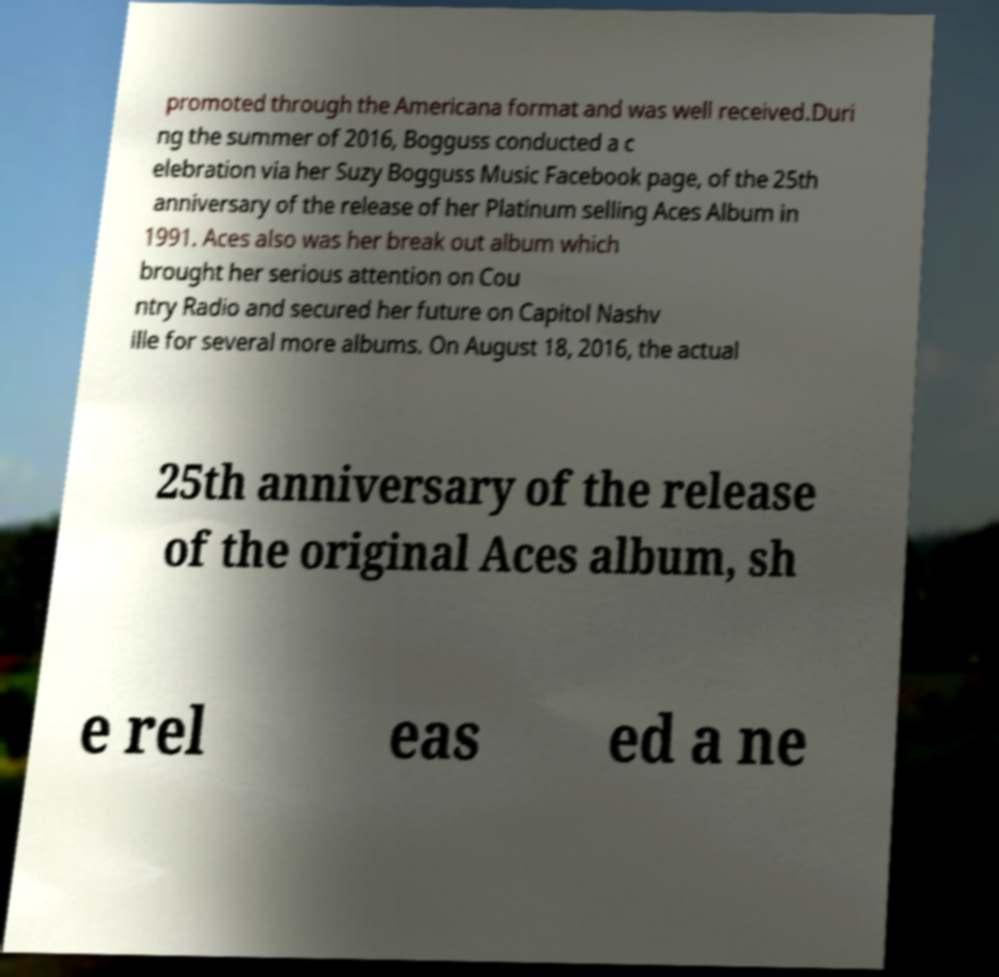There's text embedded in this image that I need extracted. Can you transcribe it verbatim? promoted through the Americana format and was well received.Duri ng the summer of 2016, Bogguss conducted a c elebration via her Suzy Bogguss Music Facebook page, of the 25th anniversary of the release of her Platinum selling Aces Album in 1991. Aces also was her break out album which brought her serious attention on Cou ntry Radio and secured her future on Capitol Nashv ille for several more albums. On August 18, 2016, the actual 25th anniversary of the release of the original Aces album, sh e rel eas ed a ne 